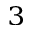Convert formula to latex. <formula><loc_0><loc_0><loc_500><loc_500>^ { 3 }</formula> 